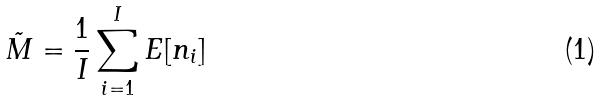<formula> <loc_0><loc_0><loc_500><loc_500>\tilde { M } = \frac { 1 } { I } \sum _ { i = 1 } ^ { I } E [ n _ { i } ]</formula> 